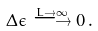Convert formula to latex. <formula><loc_0><loc_0><loc_500><loc_500>\Delta \epsilon \stackrel { L \to \infty } { \longrightarrow } 0 \, .</formula> 